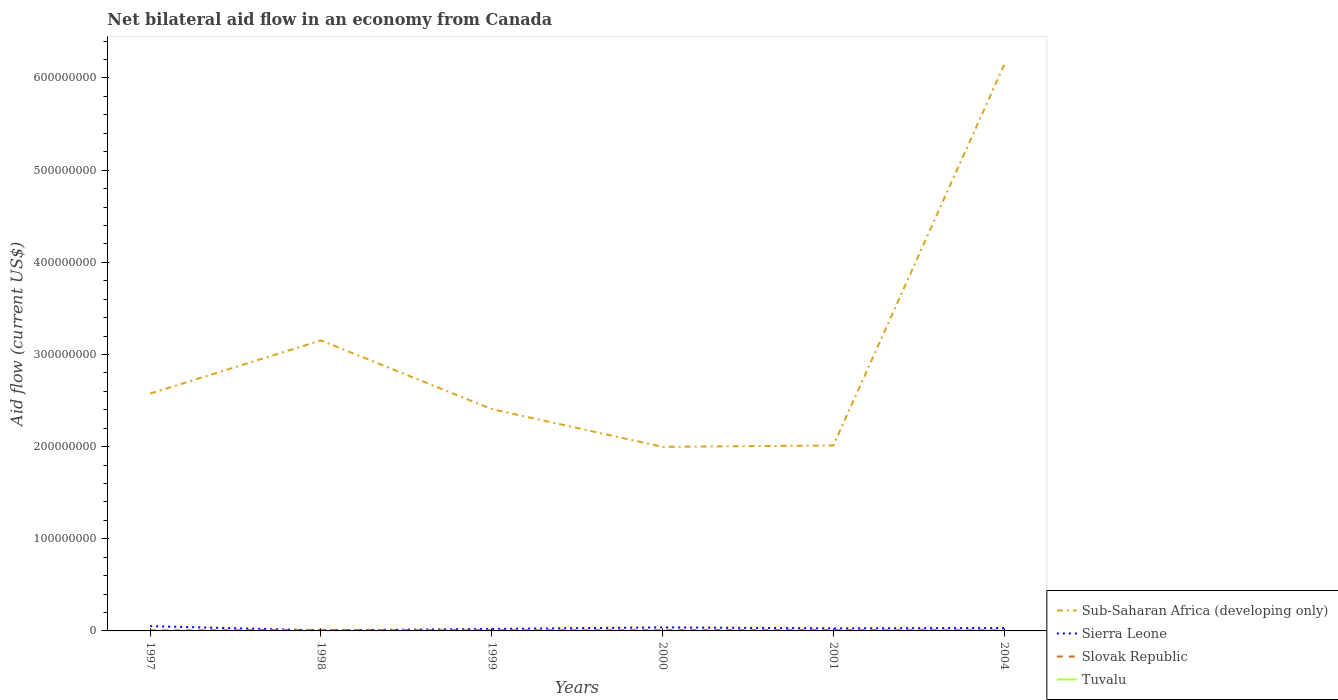Does the line corresponding to Sub-Saharan Africa (developing only) intersect with the line corresponding to Tuvalu?
Your response must be concise. No. Is the number of lines equal to the number of legend labels?
Give a very brief answer. Yes. Across all years, what is the maximum net bilateral aid flow in Sierra Leone?
Give a very brief answer. 5.80e+05. What is the total net bilateral aid flow in Sierra Leone in the graph?
Offer a very short reply. -2.19e+06. What is the difference between the highest and the second highest net bilateral aid flow in Slovak Republic?
Your answer should be compact. 5.80e+05. Is the net bilateral aid flow in Sub-Saharan Africa (developing only) strictly greater than the net bilateral aid flow in Slovak Republic over the years?
Offer a terse response. No. How many lines are there?
Your answer should be compact. 4. How many years are there in the graph?
Offer a terse response. 6. What is the difference between two consecutive major ticks on the Y-axis?
Offer a very short reply. 1.00e+08. Does the graph contain any zero values?
Give a very brief answer. No. Does the graph contain grids?
Your answer should be very brief. No. How many legend labels are there?
Provide a short and direct response. 4. How are the legend labels stacked?
Offer a very short reply. Vertical. What is the title of the graph?
Make the answer very short. Net bilateral aid flow in an economy from Canada. Does "Uruguay" appear as one of the legend labels in the graph?
Offer a terse response. No. What is the label or title of the X-axis?
Your response must be concise. Years. What is the label or title of the Y-axis?
Offer a very short reply. Aid flow (current US$). What is the Aid flow (current US$) of Sub-Saharan Africa (developing only) in 1997?
Your response must be concise. 2.58e+08. What is the Aid flow (current US$) of Sierra Leone in 1997?
Provide a succinct answer. 5.18e+06. What is the Aid flow (current US$) in Slovak Republic in 1997?
Your answer should be compact. 6.20e+05. What is the Aid flow (current US$) of Sub-Saharan Africa (developing only) in 1998?
Give a very brief answer. 3.15e+08. What is the Aid flow (current US$) in Sierra Leone in 1998?
Provide a succinct answer. 5.80e+05. What is the Aid flow (current US$) in Slovak Republic in 1998?
Your answer should be compact. 1.13e+06. What is the Aid flow (current US$) in Sub-Saharan Africa (developing only) in 1999?
Ensure brevity in your answer.  2.41e+08. What is the Aid flow (current US$) in Sierra Leone in 1999?
Give a very brief answer. 2.15e+06. What is the Aid flow (current US$) of Slovak Republic in 1999?
Provide a short and direct response. 7.10e+05. What is the Aid flow (current US$) of Sub-Saharan Africa (developing only) in 2000?
Give a very brief answer. 2.00e+08. What is the Aid flow (current US$) of Sierra Leone in 2000?
Keep it short and to the point. 3.84e+06. What is the Aid flow (current US$) of Slovak Republic in 2000?
Provide a succinct answer. 9.40e+05. What is the Aid flow (current US$) in Sub-Saharan Africa (developing only) in 2001?
Your answer should be compact. 2.01e+08. What is the Aid flow (current US$) in Sierra Leone in 2001?
Give a very brief answer. 2.77e+06. What is the Aid flow (current US$) in Slovak Republic in 2001?
Provide a succinct answer. 9.60e+05. What is the Aid flow (current US$) in Tuvalu in 2001?
Give a very brief answer. 10000. What is the Aid flow (current US$) in Sub-Saharan Africa (developing only) in 2004?
Ensure brevity in your answer.  6.14e+08. What is the Aid flow (current US$) of Sierra Leone in 2004?
Provide a short and direct response. 3.17e+06. What is the Aid flow (current US$) of Slovak Republic in 2004?
Give a very brief answer. 1.20e+06. What is the Aid flow (current US$) of Tuvalu in 2004?
Ensure brevity in your answer.  4.60e+05. Across all years, what is the maximum Aid flow (current US$) of Sub-Saharan Africa (developing only)?
Your response must be concise. 6.14e+08. Across all years, what is the maximum Aid flow (current US$) of Sierra Leone?
Offer a very short reply. 5.18e+06. Across all years, what is the maximum Aid flow (current US$) of Slovak Republic?
Provide a succinct answer. 1.20e+06. Across all years, what is the maximum Aid flow (current US$) of Tuvalu?
Provide a succinct answer. 4.60e+05. Across all years, what is the minimum Aid flow (current US$) in Sub-Saharan Africa (developing only)?
Your answer should be very brief. 2.00e+08. Across all years, what is the minimum Aid flow (current US$) in Sierra Leone?
Provide a succinct answer. 5.80e+05. Across all years, what is the minimum Aid flow (current US$) of Slovak Republic?
Give a very brief answer. 6.20e+05. What is the total Aid flow (current US$) in Sub-Saharan Africa (developing only) in the graph?
Make the answer very short. 1.83e+09. What is the total Aid flow (current US$) in Sierra Leone in the graph?
Offer a very short reply. 1.77e+07. What is the total Aid flow (current US$) in Slovak Republic in the graph?
Give a very brief answer. 5.56e+06. What is the total Aid flow (current US$) in Tuvalu in the graph?
Your response must be concise. 5.40e+05. What is the difference between the Aid flow (current US$) in Sub-Saharan Africa (developing only) in 1997 and that in 1998?
Keep it short and to the point. -5.76e+07. What is the difference between the Aid flow (current US$) in Sierra Leone in 1997 and that in 1998?
Keep it short and to the point. 4.60e+06. What is the difference between the Aid flow (current US$) of Slovak Republic in 1997 and that in 1998?
Your answer should be very brief. -5.10e+05. What is the difference between the Aid flow (current US$) of Sub-Saharan Africa (developing only) in 1997 and that in 1999?
Your answer should be very brief. 1.69e+07. What is the difference between the Aid flow (current US$) in Sierra Leone in 1997 and that in 1999?
Offer a terse response. 3.03e+06. What is the difference between the Aid flow (current US$) in Slovak Republic in 1997 and that in 1999?
Provide a succinct answer. -9.00e+04. What is the difference between the Aid flow (current US$) in Tuvalu in 1997 and that in 1999?
Your answer should be very brief. -10000. What is the difference between the Aid flow (current US$) of Sub-Saharan Africa (developing only) in 1997 and that in 2000?
Offer a terse response. 5.78e+07. What is the difference between the Aid flow (current US$) of Sierra Leone in 1997 and that in 2000?
Provide a short and direct response. 1.34e+06. What is the difference between the Aid flow (current US$) of Slovak Republic in 1997 and that in 2000?
Give a very brief answer. -3.20e+05. What is the difference between the Aid flow (current US$) in Sub-Saharan Africa (developing only) in 1997 and that in 2001?
Your answer should be compact. 5.63e+07. What is the difference between the Aid flow (current US$) in Sierra Leone in 1997 and that in 2001?
Provide a short and direct response. 2.41e+06. What is the difference between the Aid flow (current US$) in Tuvalu in 1997 and that in 2001?
Keep it short and to the point. 0. What is the difference between the Aid flow (current US$) in Sub-Saharan Africa (developing only) in 1997 and that in 2004?
Provide a short and direct response. -3.57e+08. What is the difference between the Aid flow (current US$) of Sierra Leone in 1997 and that in 2004?
Keep it short and to the point. 2.01e+06. What is the difference between the Aid flow (current US$) of Slovak Republic in 1997 and that in 2004?
Ensure brevity in your answer.  -5.80e+05. What is the difference between the Aid flow (current US$) of Tuvalu in 1997 and that in 2004?
Make the answer very short. -4.50e+05. What is the difference between the Aid flow (current US$) of Sub-Saharan Africa (developing only) in 1998 and that in 1999?
Your answer should be compact. 7.45e+07. What is the difference between the Aid flow (current US$) of Sierra Leone in 1998 and that in 1999?
Make the answer very short. -1.57e+06. What is the difference between the Aid flow (current US$) in Tuvalu in 1998 and that in 1999?
Give a very brief answer. 0. What is the difference between the Aid flow (current US$) in Sub-Saharan Africa (developing only) in 1998 and that in 2000?
Your answer should be compact. 1.15e+08. What is the difference between the Aid flow (current US$) of Sierra Leone in 1998 and that in 2000?
Offer a terse response. -3.26e+06. What is the difference between the Aid flow (current US$) in Tuvalu in 1998 and that in 2000?
Keep it short and to the point. 0. What is the difference between the Aid flow (current US$) in Sub-Saharan Africa (developing only) in 1998 and that in 2001?
Ensure brevity in your answer.  1.14e+08. What is the difference between the Aid flow (current US$) in Sierra Leone in 1998 and that in 2001?
Your answer should be very brief. -2.19e+06. What is the difference between the Aid flow (current US$) in Slovak Republic in 1998 and that in 2001?
Offer a very short reply. 1.70e+05. What is the difference between the Aid flow (current US$) in Sub-Saharan Africa (developing only) in 1998 and that in 2004?
Your response must be concise. -2.99e+08. What is the difference between the Aid flow (current US$) in Sierra Leone in 1998 and that in 2004?
Give a very brief answer. -2.59e+06. What is the difference between the Aid flow (current US$) of Slovak Republic in 1998 and that in 2004?
Keep it short and to the point. -7.00e+04. What is the difference between the Aid flow (current US$) of Tuvalu in 1998 and that in 2004?
Your response must be concise. -4.40e+05. What is the difference between the Aid flow (current US$) of Sub-Saharan Africa (developing only) in 1999 and that in 2000?
Offer a very short reply. 4.10e+07. What is the difference between the Aid flow (current US$) of Sierra Leone in 1999 and that in 2000?
Keep it short and to the point. -1.69e+06. What is the difference between the Aid flow (current US$) of Slovak Republic in 1999 and that in 2000?
Your answer should be compact. -2.30e+05. What is the difference between the Aid flow (current US$) in Sub-Saharan Africa (developing only) in 1999 and that in 2001?
Your answer should be compact. 3.94e+07. What is the difference between the Aid flow (current US$) in Sierra Leone in 1999 and that in 2001?
Make the answer very short. -6.20e+05. What is the difference between the Aid flow (current US$) of Slovak Republic in 1999 and that in 2001?
Provide a succinct answer. -2.50e+05. What is the difference between the Aid flow (current US$) in Sub-Saharan Africa (developing only) in 1999 and that in 2004?
Make the answer very short. -3.74e+08. What is the difference between the Aid flow (current US$) in Sierra Leone in 1999 and that in 2004?
Your response must be concise. -1.02e+06. What is the difference between the Aid flow (current US$) of Slovak Republic in 1999 and that in 2004?
Keep it short and to the point. -4.90e+05. What is the difference between the Aid flow (current US$) of Tuvalu in 1999 and that in 2004?
Provide a short and direct response. -4.40e+05. What is the difference between the Aid flow (current US$) of Sub-Saharan Africa (developing only) in 2000 and that in 2001?
Offer a terse response. -1.52e+06. What is the difference between the Aid flow (current US$) of Sierra Leone in 2000 and that in 2001?
Offer a very short reply. 1.07e+06. What is the difference between the Aid flow (current US$) in Tuvalu in 2000 and that in 2001?
Your answer should be very brief. 10000. What is the difference between the Aid flow (current US$) in Sub-Saharan Africa (developing only) in 2000 and that in 2004?
Ensure brevity in your answer.  -4.14e+08. What is the difference between the Aid flow (current US$) in Sierra Leone in 2000 and that in 2004?
Provide a succinct answer. 6.70e+05. What is the difference between the Aid flow (current US$) in Tuvalu in 2000 and that in 2004?
Your answer should be very brief. -4.40e+05. What is the difference between the Aid flow (current US$) of Sub-Saharan Africa (developing only) in 2001 and that in 2004?
Offer a very short reply. -4.13e+08. What is the difference between the Aid flow (current US$) of Sierra Leone in 2001 and that in 2004?
Your response must be concise. -4.00e+05. What is the difference between the Aid flow (current US$) in Tuvalu in 2001 and that in 2004?
Ensure brevity in your answer.  -4.50e+05. What is the difference between the Aid flow (current US$) of Sub-Saharan Africa (developing only) in 1997 and the Aid flow (current US$) of Sierra Leone in 1998?
Give a very brief answer. 2.57e+08. What is the difference between the Aid flow (current US$) in Sub-Saharan Africa (developing only) in 1997 and the Aid flow (current US$) in Slovak Republic in 1998?
Keep it short and to the point. 2.56e+08. What is the difference between the Aid flow (current US$) of Sub-Saharan Africa (developing only) in 1997 and the Aid flow (current US$) of Tuvalu in 1998?
Keep it short and to the point. 2.58e+08. What is the difference between the Aid flow (current US$) of Sierra Leone in 1997 and the Aid flow (current US$) of Slovak Republic in 1998?
Your answer should be very brief. 4.05e+06. What is the difference between the Aid flow (current US$) of Sierra Leone in 1997 and the Aid flow (current US$) of Tuvalu in 1998?
Provide a short and direct response. 5.16e+06. What is the difference between the Aid flow (current US$) of Slovak Republic in 1997 and the Aid flow (current US$) of Tuvalu in 1998?
Offer a very short reply. 6.00e+05. What is the difference between the Aid flow (current US$) in Sub-Saharan Africa (developing only) in 1997 and the Aid flow (current US$) in Sierra Leone in 1999?
Your response must be concise. 2.55e+08. What is the difference between the Aid flow (current US$) in Sub-Saharan Africa (developing only) in 1997 and the Aid flow (current US$) in Slovak Republic in 1999?
Provide a succinct answer. 2.57e+08. What is the difference between the Aid flow (current US$) of Sub-Saharan Africa (developing only) in 1997 and the Aid flow (current US$) of Tuvalu in 1999?
Your answer should be very brief. 2.58e+08. What is the difference between the Aid flow (current US$) in Sierra Leone in 1997 and the Aid flow (current US$) in Slovak Republic in 1999?
Your answer should be very brief. 4.47e+06. What is the difference between the Aid flow (current US$) of Sierra Leone in 1997 and the Aid flow (current US$) of Tuvalu in 1999?
Offer a very short reply. 5.16e+06. What is the difference between the Aid flow (current US$) of Slovak Republic in 1997 and the Aid flow (current US$) of Tuvalu in 1999?
Ensure brevity in your answer.  6.00e+05. What is the difference between the Aid flow (current US$) in Sub-Saharan Africa (developing only) in 1997 and the Aid flow (current US$) in Sierra Leone in 2000?
Ensure brevity in your answer.  2.54e+08. What is the difference between the Aid flow (current US$) of Sub-Saharan Africa (developing only) in 1997 and the Aid flow (current US$) of Slovak Republic in 2000?
Give a very brief answer. 2.57e+08. What is the difference between the Aid flow (current US$) of Sub-Saharan Africa (developing only) in 1997 and the Aid flow (current US$) of Tuvalu in 2000?
Make the answer very short. 2.58e+08. What is the difference between the Aid flow (current US$) in Sierra Leone in 1997 and the Aid flow (current US$) in Slovak Republic in 2000?
Your answer should be compact. 4.24e+06. What is the difference between the Aid flow (current US$) of Sierra Leone in 1997 and the Aid flow (current US$) of Tuvalu in 2000?
Provide a succinct answer. 5.16e+06. What is the difference between the Aid flow (current US$) of Sub-Saharan Africa (developing only) in 1997 and the Aid flow (current US$) of Sierra Leone in 2001?
Make the answer very short. 2.55e+08. What is the difference between the Aid flow (current US$) in Sub-Saharan Africa (developing only) in 1997 and the Aid flow (current US$) in Slovak Republic in 2001?
Provide a succinct answer. 2.57e+08. What is the difference between the Aid flow (current US$) of Sub-Saharan Africa (developing only) in 1997 and the Aid flow (current US$) of Tuvalu in 2001?
Make the answer very short. 2.58e+08. What is the difference between the Aid flow (current US$) of Sierra Leone in 1997 and the Aid flow (current US$) of Slovak Republic in 2001?
Provide a short and direct response. 4.22e+06. What is the difference between the Aid flow (current US$) of Sierra Leone in 1997 and the Aid flow (current US$) of Tuvalu in 2001?
Provide a short and direct response. 5.17e+06. What is the difference between the Aid flow (current US$) of Slovak Republic in 1997 and the Aid flow (current US$) of Tuvalu in 2001?
Your answer should be very brief. 6.10e+05. What is the difference between the Aid flow (current US$) in Sub-Saharan Africa (developing only) in 1997 and the Aid flow (current US$) in Sierra Leone in 2004?
Keep it short and to the point. 2.54e+08. What is the difference between the Aid flow (current US$) of Sub-Saharan Africa (developing only) in 1997 and the Aid flow (current US$) of Slovak Republic in 2004?
Your answer should be very brief. 2.56e+08. What is the difference between the Aid flow (current US$) of Sub-Saharan Africa (developing only) in 1997 and the Aid flow (current US$) of Tuvalu in 2004?
Make the answer very short. 2.57e+08. What is the difference between the Aid flow (current US$) of Sierra Leone in 1997 and the Aid flow (current US$) of Slovak Republic in 2004?
Your answer should be compact. 3.98e+06. What is the difference between the Aid flow (current US$) in Sierra Leone in 1997 and the Aid flow (current US$) in Tuvalu in 2004?
Ensure brevity in your answer.  4.72e+06. What is the difference between the Aid flow (current US$) of Sub-Saharan Africa (developing only) in 1998 and the Aid flow (current US$) of Sierra Leone in 1999?
Keep it short and to the point. 3.13e+08. What is the difference between the Aid flow (current US$) of Sub-Saharan Africa (developing only) in 1998 and the Aid flow (current US$) of Slovak Republic in 1999?
Your answer should be very brief. 3.15e+08. What is the difference between the Aid flow (current US$) in Sub-Saharan Africa (developing only) in 1998 and the Aid flow (current US$) in Tuvalu in 1999?
Provide a short and direct response. 3.15e+08. What is the difference between the Aid flow (current US$) in Sierra Leone in 1998 and the Aid flow (current US$) in Slovak Republic in 1999?
Your response must be concise. -1.30e+05. What is the difference between the Aid flow (current US$) in Sierra Leone in 1998 and the Aid flow (current US$) in Tuvalu in 1999?
Your answer should be very brief. 5.60e+05. What is the difference between the Aid flow (current US$) in Slovak Republic in 1998 and the Aid flow (current US$) in Tuvalu in 1999?
Give a very brief answer. 1.11e+06. What is the difference between the Aid flow (current US$) of Sub-Saharan Africa (developing only) in 1998 and the Aid flow (current US$) of Sierra Leone in 2000?
Make the answer very short. 3.11e+08. What is the difference between the Aid flow (current US$) in Sub-Saharan Africa (developing only) in 1998 and the Aid flow (current US$) in Slovak Republic in 2000?
Provide a short and direct response. 3.14e+08. What is the difference between the Aid flow (current US$) of Sub-Saharan Africa (developing only) in 1998 and the Aid flow (current US$) of Tuvalu in 2000?
Your answer should be compact. 3.15e+08. What is the difference between the Aid flow (current US$) of Sierra Leone in 1998 and the Aid flow (current US$) of Slovak Republic in 2000?
Your answer should be very brief. -3.60e+05. What is the difference between the Aid flow (current US$) of Sierra Leone in 1998 and the Aid flow (current US$) of Tuvalu in 2000?
Make the answer very short. 5.60e+05. What is the difference between the Aid flow (current US$) of Slovak Republic in 1998 and the Aid flow (current US$) of Tuvalu in 2000?
Your answer should be very brief. 1.11e+06. What is the difference between the Aid flow (current US$) in Sub-Saharan Africa (developing only) in 1998 and the Aid flow (current US$) in Sierra Leone in 2001?
Your answer should be very brief. 3.12e+08. What is the difference between the Aid flow (current US$) of Sub-Saharan Africa (developing only) in 1998 and the Aid flow (current US$) of Slovak Republic in 2001?
Your response must be concise. 3.14e+08. What is the difference between the Aid flow (current US$) of Sub-Saharan Africa (developing only) in 1998 and the Aid flow (current US$) of Tuvalu in 2001?
Provide a short and direct response. 3.15e+08. What is the difference between the Aid flow (current US$) of Sierra Leone in 1998 and the Aid flow (current US$) of Slovak Republic in 2001?
Your response must be concise. -3.80e+05. What is the difference between the Aid flow (current US$) in Sierra Leone in 1998 and the Aid flow (current US$) in Tuvalu in 2001?
Provide a short and direct response. 5.70e+05. What is the difference between the Aid flow (current US$) in Slovak Republic in 1998 and the Aid flow (current US$) in Tuvalu in 2001?
Your answer should be compact. 1.12e+06. What is the difference between the Aid flow (current US$) in Sub-Saharan Africa (developing only) in 1998 and the Aid flow (current US$) in Sierra Leone in 2004?
Ensure brevity in your answer.  3.12e+08. What is the difference between the Aid flow (current US$) of Sub-Saharan Africa (developing only) in 1998 and the Aid flow (current US$) of Slovak Republic in 2004?
Your answer should be very brief. 3.14e+08. What is the difference between the Aid flow (current US$) in Sub-Saharan Africa (developing only) in 1998 and the Aid flow (current US$) in Tuvalu in 2004?
Your response must be concise. 3.15e+08. What is the difference between the Aid flow (current US$) in Sierra Leone in 1998 and the Aid flow (current US$) in Slovak Republic in 2004?
Ensure brevity in your answer.  -6.20e+05. What is the difference between the Aid flow (current US$) in Sierra Leone in 1998 and the Aid flow (current US$) in Tuvalu in 2004?
Ensure brevity in your answer.  1.20e+05. What is the difference between the Aid flow (current US$) of Slovak Republic in 1998 and the Aid flow (current US$) of Tuvalu in 2004?
Offer a terse response. 6.70e+05. What is the difference between the Aid flow (current US$) in Sub-Saharan Africa (developing only) in 1999 and the Aid flow (current US$) in Sierra Leone in 2000?
Ensure brevity in your answer.  2.37e+08. What is the difference between the Aid flow (current US$) of Sub-Saharan Africa (developing only) in 1999 and the Aid flow (current US$) of Slovak Republic in 2000?
Your response must be concise. 2.40e+08. What is the difference between the Aid flow (current US$) in Sub-Saharan Africa (developing only) in 1999 and the Aid flow (current US$) in Tuvalu in 2000?
Your answer should be compact. 2.41e+08. What is the difference between the Aid flow (current US$) of Sierra Leone in 1999 and the Aid flow (current US$) of Slovak Republic in 2000?
Your answer should be compact. 1.21e+06. What is the difference between the Aid flow (current US$) of Sierra Leone in 1999 and the Aid flow (current US$) of Tuvalu in 2000?
Your response must be concise. 2.13e+06. What is the difference between the Aid flow (current US$) in Slovak Republic in 1999 and the Aid flow (current US$) in Tuvalu in 2000?
Your response must be concise. 6.90e+05. What is the difference between the Aid flow (current US$) of Sub-Saharan Africa (developing only) in 1999 and the Aid flow (current US$) of Sierra Leone in 2001?
Your answer should be very brief. 2.38e+08. What is the difference between the Aid flow (current US$) of Sub-Saharan Africa (developing only) in 1999 and the Aid flow (current US$) of Slovak Republic in 2001?
Make the answer very short. 2.40e+08. What is the difference between the Aid flow (current US$) of Sub-Saharan Africa (developing only) in 1999 and the Aid flow (current US$) of Tuvalu in 2001?
Your answer should be very brief. 2.41e+08. What is the difference between the Aid flow (current US$) in Sierra Leone in 1999 and the Aid flow (current US$) in Slovak Republic in 2001?
Give a very brief answer. 1.19e+06. What is the difference between the Aid flow (current US$) of Sierra Leone in 1999 and the Aid flow (current US$) of Tuvalu in 2001?
Provide a short and direct response. 2.14e+06. What is the difference between the Aid flow (current US$) in Slovak Republic in 1999 and the Aid flow (current US$) in Tuvalu in 2001?
Your response must be concise. 7.00e+05. What is the difference between the Aid flow (current US$) of Sub-Saharan Africa (developing only) in 1999 and the Aid flow (current US$) of Sierra Leone in 2004?
Provide a short and direct response. 2.38e+08. What is the difference between the Aid flow (current US$) of Sub-Saharan Africa (developing only) in 1999 and the Aid flow (current US$) of Slovak Republic in 2004?
Offer a terse response. 2.39e+08. What is the difference between the Aid flow (current US$) of Sub-Saharan Africa (developing only) in 1999 and the Aid flow (current US$) of Tuvalu in 2004?
Keep it short and to the point. 2.40e+08. What is the difference between the Aid flow (current US$) of Sierra Leone in 1999 and the Aid flow (current US$) of Slovak Republic in 2004?
Your answer should be very brief. 9.50e+05. What is the difference between the Aid flow (current US$) in Sierra Leone in 1999 and the Aid flow (current US$) in Tuvalu in 2004?
Ensure brevity in your answer.  1.69e+06. What is the difference between the Aid flow (current US$) in Sub-Saharan Africa (developing only) in 2000 and the Aid flow (current US$) in Sierra Leone in 2001?
Provide a succinct answer. 1.97e+08. What is the difference between the Aid flow (current US$) of Sub-Saharan Africa (developing only) in 2000 and the Aid flow (current US$) of Slovak Republic in 2001?
Keep it short and to the point. 1.99e+08. What is the difference between the Aid flow (current US$) in Sub-Saharan Africa (developing only) in 2000 and the Aid flow (current US$) in Tuvalu in 2001?
Your response must be concise. 2.00e+08. What is the difference between the Aid flow (current US$) in Sierra Leone in 2000 and the Aid flow (current US$) in Slovak Republic in 2001?
Offer a very short reply. 2.88e+06. What is the difference between the Aid flow (current US$) in Sierra Leone in 2000 and the Aid flow (current US$) in Tuvalu in 2001?
Your answer should be very brief. 3.83e+06. What is the difference between the Aid flow (current US$) of Slovak Republic in 2000 and the Aid flow (current US$) of Tuvalu in 2001?
Keep it short and to the point. 9.30e+05. What is the difference between the Aid flow (current US$) of Sub-Saharan Africa (developing only) in 2000 and the Aid flow (current US$) of Sierra Leone in 2004?
Give a very brief answer. 1.97e+08. What is the difference between the Aid flow (current US$) of Sub-Saharan Africa (developing only) in 2000 and the Aid flow (current US$) of Slovak Republic in 2004?
Your answer should be very brief. 1.99e+08. What is the difference between the Aid flow (current US$) of Sub-Saharan Africa (developing only) in 2000 and the Aid flow (current US$) of Tuvalu in 2004?
Your response must be concise. 1.99e+08. What is the difference between the Aid flow (current US$) of Sierra Leone in 2000 and the Aid flow (current US$) of Slovak Republic in 2004?
Your response must be concise. 2.64e+06. What is the difference between the Aid flow (current US$) in Sierra Leone in 2000 and the Aid flow (current US$) in Tuvalu in 2004?
Provide a succinct answer. 3.38e+06. What is the difference between the Aid flow (current US$) in Slovak Republic in 2000 and the Aid flow (current US$) in Tuvalu in 2004?
Offer a very short reply. 4.80e+05. What is the difference between the Aid flow (current US$) of Sub-Saharan Africa (developing only) in 2001 and the Aid flow (current US$) of Sierra Leone in 2004?
Keep it short and to the point. 1.98e+08. What is the difference between the Aid flow (current US$) of Sub-Saharan Africa (developing only) in 2001 and the Aid flow (current US$) of Slovak Republic in 2004?
Your answer should be compact. 2.00e+08. What is the difference between the Aid flow (current US$) of Sub-Saharan Africa (developing only) in 2001 and the Aid flow (current US$) of Tuvalu in 2004?
Your answer should be very brief. 2.01e+08. What is the difference between the Aid flow (current US$) of Sierra Leone in 2001 and the Aid flow (current US$) of Slovak Republic in 2004?
Provide a succinct answer. 1.57e+06. What is the difference between the Aid flow (current US$) in Sierra Leone in 2001 and the Aid flow (current US$) in Tuvalu in 2004?
Make the answer very short. 2.31e+06. What is the average Aid flow (current US$) in Sub-Saharan Africa (developing only) per year?
Offer a terse response. 3.05e+08. What is the average Aid flow (current US$) in Sierra Leone per year?
Keep it short and to the point. 2.95e+06. What is the average Aid flow (current US$) of Slovak Republic per year?
Your response must be concise. 9.27e+05. What is the average Aid flow (current US$) in Tuvalu per year?
Give a very brief answer. 9.00e+04. In the year 1997, what is the difference between the Aid flow (current US$) of Sub-Saharan Africa (developing only) and Aid flow (current US$) of Sierra Leone?
Offer a terse response. 2.52e+08. In the year 1997, what is the difference between the Aid flow (current US$) in Sub-Saharan Africa (developing only) and Aid flow (current US$) in Slovak Republic?
Ensure brevity in your answer.  2.57e+08. In the year 1997, what is the difference between the Aid flow (current US$) of Sub-Saharan Africa (developing only) and Aid flow (current US$) of Tuvalu?
Make the answer very short. 2.58e+08. In the year 1997, what is the difference between the Aid flow (current US$) of Sierra Leone and Aid flow (current US$) of Slovak Republic?
Ensure brevity in your answer.  4.56e+06. In the year 1997, what is the difference between the Aid flow (current US$) in Sierra Leone and Aid flow (current US$) in Tuvalu?
Offer a very short reply. 5.17e+06. In the year 1998, what is the difference between the Aid flow (current US$) in Sub-Saharan Africa (developing only) and Aid flow (current US$) in Sierra Leone?
Your answer should be very brief. 3.15e+08. In the year 1998, what is the difference between the Aid flow (current US$) in Sub-Saharan Africa (developing only) and Aid flow (current US$) in Slovak Republic?
Provide a succinct answer. 3.14e+08. In the year 1998, what is the difference between the Aid flow (current US$) of Sub-Saharan Africa (developing only) and Aid flow (current US$) of Tuvalu?
Your answer should be very brief. 3.15e+08. In the year 1998, what is the difference between the Aid flow (current US$) of Sierra Leone and Aid flow (current US$) of Slovak Republic?
Make the answer very short. -5.50e+05. In the year 1998, what is the difference between the Aid flow (current US$) in Sierra Leone and Aid flow (current US$) in Tuvalu?
Keep it short and to the point. 5.60e+05. In the year 1998, what is the difference between the Aid flow (current US$) in Slovak Republic and Aid flow (current US$) in Tuvalu?
Make the answer very short. 1.11e+06. In the year 1999, what is the difference between the Aid flow (current US$) in Sub-Saharan Africa (developing only) and Aid flow (current US$) in Sierra Leone?
Offer a very short reply. 2.39e+08. In the year 1999, what is the difference between the Aid flow (current US$) in Sub-Saharan Africa (developing only) and Aid flow (current US$) in Slovak Republic?
Provide a succinct answer. 2.40e+08. In the year 1999, what is the difference between the Aid flow (current US$) in Sub-Saharan Africa (developing only) and Aid flow (current US$) in Tuvalu?
Offer a very short reply. 2.41e+08. In the year 1999, what is the difference between the Aid flow (current US$) in Sierra Leone and Aid flow (current US$) in Slovak Republic?
Provide a short and direct response. 1.44e+06. In the year 1999, what is the difference between the Aid flow (current US$) of Sierra Leone and Aid flow (current US$) of Tuvalu?
Make the answer very short. 2.13e+06. In the year 1999, what is the difference between the Aid flow (current US$) of Slovak Republic and Aid flow (current US$) of Tuvalu?
Make the answer very short. 6.90e+05. In the year 2000, what is the difference between the Aid flow (current US$) of Sub-Saharan Africa (developing only) and Aid flow (current US$) of Sierra Leone?
Your answer should be compact. 1.96e+08. In the year 2000, what is the difference between the Aid flow (current US$) of Sub-Saharan Africa (developing only) and Aid flow (current US$) of Slovak Republic?
Ensure brevity in your answer.  1.99e+08. In the year 2000, what is the difference between the Aid flow (current US$) of Sub-Saharan Africa (developing only) and Aid flow (current US$) of Tuvalu?
Provide a succinct answer. 2.00e+08. In the year 2000, what is the difference between the Aid flow (current US$) in Sierra Leone and Aid flow (current US$) in Slovak Republic?
Give a very brief answer. 2.90e+06. In the year 2000, what is the difference between the Aid flow (current US$) in Sierra Leone and Aid flow (current US$) in Tuvalu?
Give a very brief answer. 3.82e+06. In the year 2000, what is the difference between the Aid flow (current US$) in Slovak Republic and Aid flow (current US$) in Tuvalu?
Offer a terse response. 9.20e+05. In the year 2001, what is the difference between the Aid flow (current US$) in Sub-Saharan Africa (developing only) and Aid flow (current US$) in Sierra Leone?
Your response must be concise. 1.98e+08. In the year 2001, what is the difference between the Aid flow (current US$) in Sub-Saharan Africa (developing only) and Aid flow (current US$) in Slovak Republic?
Offer a very short reply. 2.00e+08. In the year 2001, what is the difference between the Aid flow (current US$) in Sub-Saharan Africa (developing only) and Aid flow (current US$) in Tuvalu?
Offer a terse response. 2.01e+08. In the year 2001, what is the difference between the Aid flow (current US$) in Sierra Leone and Aid flow (current US$) in Slovak Republic?
Give a very brief answer. 1.81e+06. In the year 2001, what is the difference between the Aid flow (current US$) in Sierra Leone and Aid flow (current US$) in Tuvalu?
Your answer should be compact. 2.76e+06. In the year 2001, what is the difference between the Aid flow (current US$) of Slovak Republic and Aid flow (current US$) of Tuvalu?
Your response must be concise. 9.50e+05. In the year 2004, what is the difference between the Aid flow (current US$) of Sub-Saharan Africa (developing only) and Aid flow (current US$) of Sierra Leone?
Provide a succinct answer. 6.11e+08. In the year 2004, what is the difference between the Aid flow (current US$) in Sub-Saharan Africa (developing only) and Aid flow (current US$) in Slovak Republic?
Provide a short and direct response. 6.13e+08. In the year 2004, what is the difference between the Aid flow (current US$) in Sub-Saharan Africa (developing only) and Aid flow (current US$) in Tuvalu?
Ensure brevity in your answer.  6.14e+08. In the year 2004, what is the difference between the Aid flow (current US$) of Sierra Leone and Aid flow (current US$) of Slovak Republic?
Make the answer very short. 1.97e+06. In the year 2004, what is the difference between the Aid flow (current US$) of Sierra Leone and Aid flow (current US$) of Tuvalu?
Provide a succinct answer. 2.71e+06. In the year 2004, what is the difference between the Aid flow (current US$) in Slovak Republic and Aid flow (current US$) in Tuvalu?
Your answer should be compact. 7.40e+05. What is the ratio of the Aid flow (current US$) in Sub-Saharan Africa (developing only) in 1997 to that in 1998?
Your response must be concise. 0.82. What is the ratio of the Aid flow (current US$) of Sierra Leone in 1997 to that in 1998?
Your answer should be very brief. 8.93. What is the ratio of the Aid flow (current US$) of Slovak Republic in 1997 to that in 1998?
Your answer should be very brief. 0.55. What is the ratio of the Aid flow (current US$) of Tuvalu in 1997 to that in 1998?
Give a very brief answer. 0.5. What is the ratio of the Aid flow (current US$) in Sub-Saharan Africa (developing only) in 1997 to that in 1999?
Give a very brief answer. 1.07. What is the ratio of the Aid flow (current US$) in Sierra Leone in 1997 to that in 1999?
Your answer should be compact. 2.41. What is the ratio of the Aid flow (current US$) in Slovak Republic in 1997 to that in 1999?
Make the answer very short. 0.87. What is the ratio of the Aid flow (current US$) in Tuvalu in 1997 to that in 1999?
Make the answer very short. 0.5. What is the ratio of the Aid flow (current US$) of Sub-Saharan Africa (developing only) in 1997 to that in 2000?
Your response must be concise. 1.29. What is the ratio of the Aid flow (current US$) in Sierra Leone in 1997 to that in 2000?
Offer a terse response. 1.35. What is the ratio of the Aid flow (current US$) in Slovak Republic in 1997 to that in 2000?
Offer a very short reply. 0.66. What is the ratio of the Aid flow (current US$) in Tuvalu in 1997 to that in 2000?
Your answer should be very brief. 0.5. What is the ratio of the Aid flow (current US$) in Sub-Saharan Africa (developing only) in 1997 to that in 2001?
Provide a succinct answer. 1.28. What is the ratio of the Aid flow (current US$) in Sierra Leone in 1997 to that in 2001?
Keep it short and to the point. 1.87. What is the ratio of the Aid flow (current US$) in Slovak Republic in 1997 to that in 2001?
Give a very brief answer. 0.65. What is the ratio of the Aid flow (current US$) of Tuvalu in 1997 to that in 2001?
Offer a terse response. 1. What is the ratio of the Aid flow (current US$) of Sub-Saharan Africa (developing only) in 1997 to that in 2004?
Provide a succinct answer. 0.42. What is the ratio of the Aid flow (current US$) of Sierra Leone in 1997 to that in 2004?
Make the answer very short. 1.63. What is the ratio of the Aid flow (current US$) in Slovak Republic in 1997 to that in 2004?
Make the answer very short. 0.52. What is the ratio of the Aid flow (current US$) of Tuvalu in 1997 to that in 2004?
Your response must be concise. 0.02. What is the ratio of the Aid flow (current US$) in Sub-Saharan Africa (developing only) in 1998 to that in 1999?
Offer a very short reply. 1.31. What is the ratio of the Aid flow (current US$) in Sierra Leone in 1998 to that in 1999?
Your answer should be compact. 0.27. What is the ratio of the Aid flow (current US$) of Slovak Republic in 1998 to that in 1999?
Your answer should be compact. 1.59. What is the ratio of the Aid flow (current US$) in Tuvalu in 1998 to that in 1999?
Ensure brevity in your answer.  1. What is the ratio of the Aid flow (current US$) of Sub-Saharan Africa (developing only) in 1998 to that in 2000?
Your response must be concise. 1.58. What is the ratio of the Aid flow (current US$) in Sierra Leone in 1998 to that in 2000?
Your answer should be very brief. 0.15. What is the ratio of the Aid flow (current US$) in Slovak Republic in 1998 to that in 2000?
Your answer should be compact. 1.2. What is the ratio of the Aid flow (current US$) in Tuvalu in 1998 to that in 2000?
Your answer should be compact. 1. What is the ratio of the Aid flow (current US$) in Sub-Saharan Africa (developing only) in 1998 to that in 2001?
Your response must be concise. 1.57. What is the ratio of the Aid flow (current US$) in Sierra Leone in 1998 to that in 2001?
Your response must be concise. 0.21. What is the ratio of the Aid flow (current US$) in Slovak Republic in 1998 to that in 2001?
Your answer should be very brief. 1.18. What is the ratio of the Aid flow (current US$) in Sub-Saharan Africa (developing only) in 1998 to that in 2004?
Your answer should be very brief. 0.51. What is the ratio of the Aid flow (current US$) of Sierra Leone in 1998 to that in 2004?
Your answer should be very brief. 0.18. What is the ratio of the Aid flow (current US$) in Slovak Republic in 1998 to that in 2004?
Offer a very short reply. 0.94. What is the ratio of the Aid flow (current US$) in Tuvalu in 1998 to that in 2004?
Ensure brevity in your answer.  0.04. What is the ratio of the Aid flow (current US$) of Sub-Saharan Africa (developing only) in 1999 to that in 2000?
Ensure brevity in your answer.  1.21. What is the ratio of the Aid flow (current US$) of Sierra Leone in 1999 to that in 2000?
Offer a very short reply. 0.56. What is the ratio of the Aid flow (current US$) of Slovak Republic in 1999 to that in 2000?
Offer a terse response. 0.76. What is the ratio of the Aid flow (current US$) in Tuvalu in 1999 to that in 2000?
Ensure brevity in your answer.  1. What is the ratio of the Aid flow (current US$) of Sub-Saharan Africa (developing only) in 1999 to that in 2001?
Offer a terse response. 1.2. What is the ratio of the Aid flow (current US$) of Sierra Leone in 1999 to that in 2001?
Make the answer very short. 0.78. What is the ratio of the Aid flow (current US$) of Slovak Republic in 1999 to that in 2001?
Your answer should be compact. 0.74. What is the ratio of the Aid flow (current US$) of Tuvalu in 1999 to that in 2001?
Offer a terse response. 2. What is the ratio of the Aid flow (current US$) of Sub-Saharan Africa (developing only) in 1999 to that in 2004?
Provide a succinct answer. 0.39. What is the ratio of the Aid flow (current US$) in Sierra Leone in 1999 to that in 2004?
Offer a very short reply. 0.68. What is the ratio of the Aid flow (current US$) in Slovak Republic in 1999 to that in 2004?
Your answer should be compact. 0.59. What is the ratio of the Aid flow (current US$) of Tuvalu in 1999 to that in 2004?
Your answer should be very brief. 0.04. What is the ratio of the Aid flow (current US$) in Sub-Saharan Africa (developing only) in 2000 to that in 2001?
Provide a succinct answer. 0.99. What is the ratio of the Aid flow (current US$) in Sierra Leone in 2000 to that in 2001?
Offer a very short reply. 1.39. What is the ratio of the Aid flow (current US$) of Slovak Republic in 2000 to that in 2001?
Offer a terse response. 0.98. What is the ratio of the Aid flow (current US$) of Tuvalu in 2000 to that in 2001?
Your answer should be compact. 2. What is the ratio of the Aid flow (current US$) of Sub-Saharan Africa (developing only) in 2000 to that in 2004?
Offer a terse response. 0.33. What is the ratio of the Aid flow (current US$) in Sierra Leone in 2000 to that in 2004?
Keep it short and to the point. 1.21. What is the ratio of the Aid flow (current US$) of Slovak Republic in 2000 to that in 2004?
Your answer should be compact. 0.78. What is the ratio of the Aid flow (current US$) in Tuvalu in 2000 to that in 2004?
Your answer should be compact. 0.04. What is the ratio of the Aid flow (current US$) of Sub-Saharan Africa (developing only) in 2001 to that in 2004?
Keep it short and to the point. 0.33. What is the ratio of the Aid flow (current US$) in Sierra Leone in 2001 to that in 2004?
Your answer should be compact. 0.87. What is the ratio of the Aid flow (current US$) of Tuvalu in 2001 to that in 2004?
Your response must be concise. 0.02. What is the difference between the highest and the second highest Aid flow (current US$) in Sub-Saharan Africa (developing only)?
Offer a very short reply. 2.99e+08. What is the difference between the highest and the second highest Aid flow (current US$) of Sierra Leone?
Provide a short and direct response. 1.34e+06. What is the difference between the highest and the second highest Aid flow (current US$) of Tuvalu?
Keep it short and to the point. 4.40e+05. What is the difference between the highest and the lowest Aid flow (current US$) in Sub-Saharan Africa (developing only)?
Give a very brief answer. 4.14e+08. What is the difference between the highest and the lowest Aid flow (current US$) of Sierra Leone?
Make the answer very short. 4.60e+06. What is the difference between the highest and the lowest Aid flow (current US$) in Slovak Republic?
Offer a very short reply. 5.80e+05. What is the difference between the highest and the lowest Aid flow (current US$) in Tuvalu?
Offer a very short reply. 4.50e+05. 